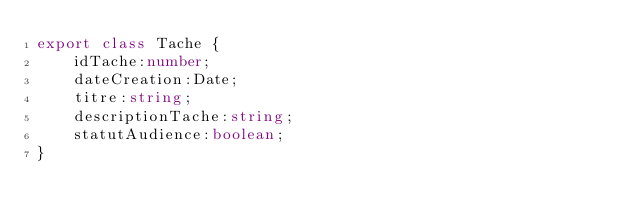<code> <loc_0><loc_0><loc_500><loc_500><_TypeScript_>export class Tache {
    idTache:number;
    dateCreation:Date;
    titre:string;
    descriptionTache:string;
    statutAudience:boolean;
}
</code> 